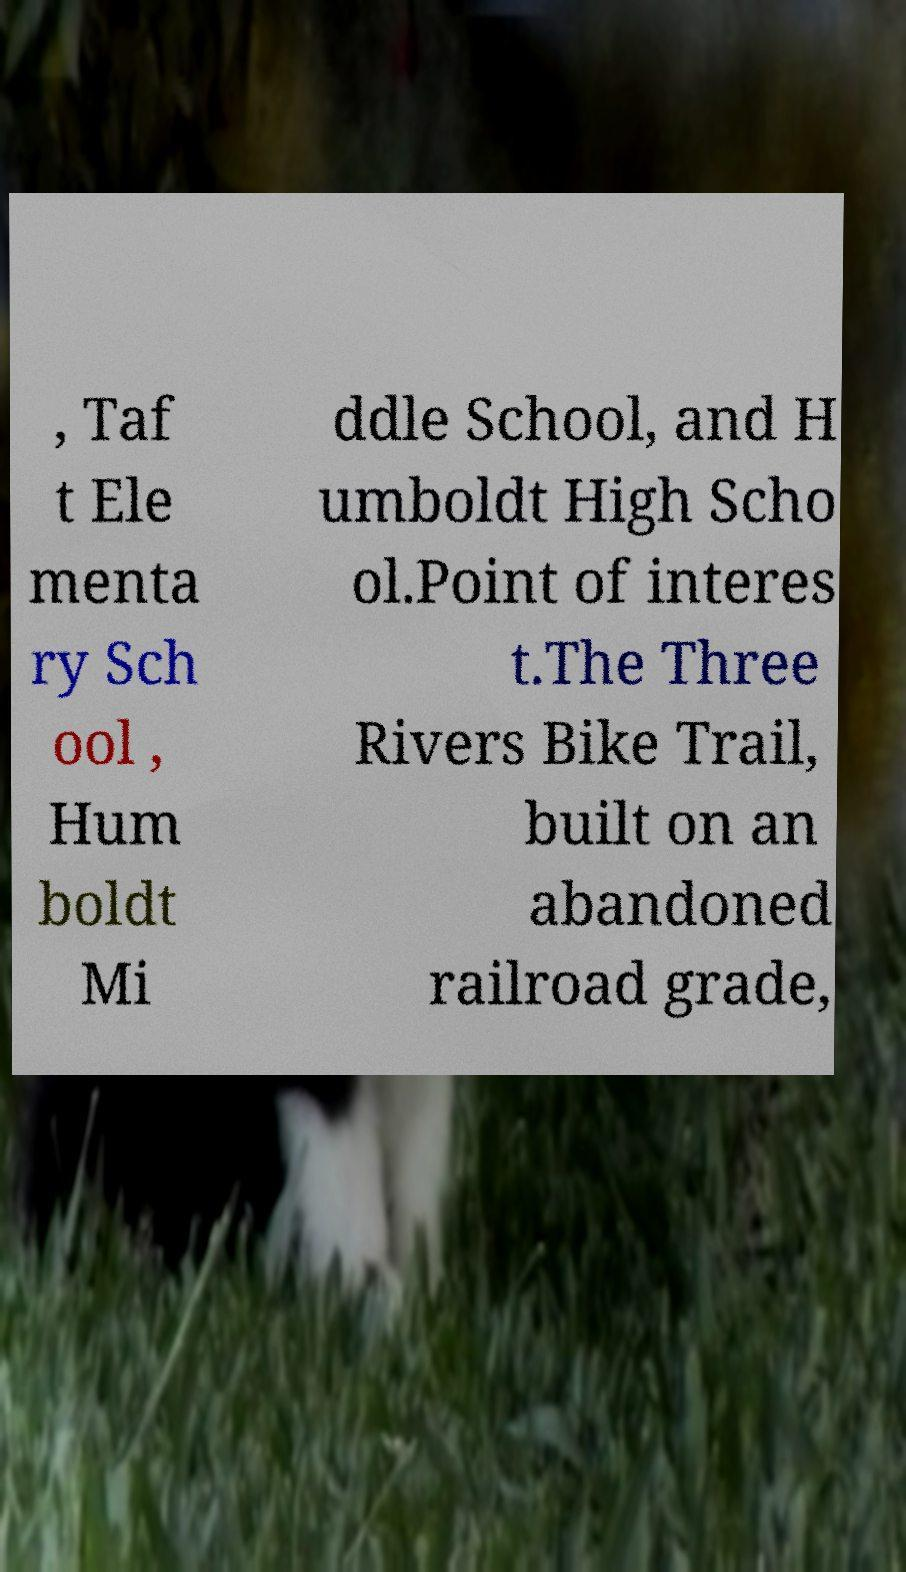There's text embedded in this image that I need extracted. Can you transcribe it verbatim? , Taf t Ele menta ry Sch ool , Hum boldt Mi ddle School, and H umboldt High Scho ol.Point of interes t.The Three Rivers Bike Trail, built on an abandoned railroad grade, 